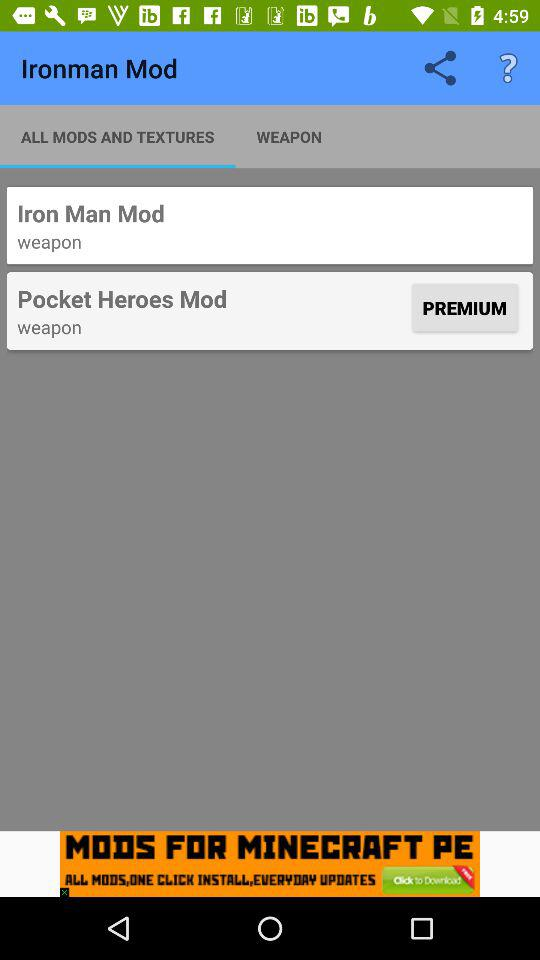What is the name of the application? The name of the application is "Ironman Mod". 